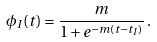Convert formula to latex. <formula><loc_0><loc_0><loc_500><loc_500>\phi _ { I } ( t ) = \frac { m } { 1 + e ^ { - m ( t - t _ { I } ) } } \, .</formula> 